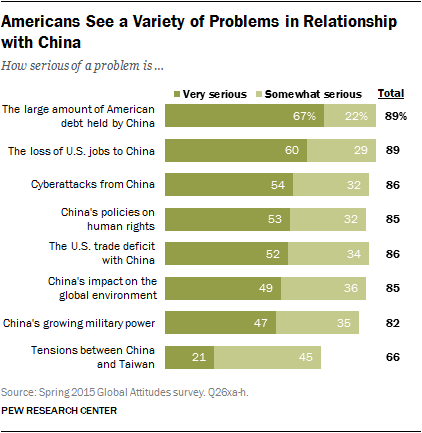List a handful of essential elements in this visual. The problem with the longest dark green bar is the large amount of American debt held by China. The sum of "very serious" and "somewhat serious" problems related to tensions between China and Taiwan is 0.66%. 